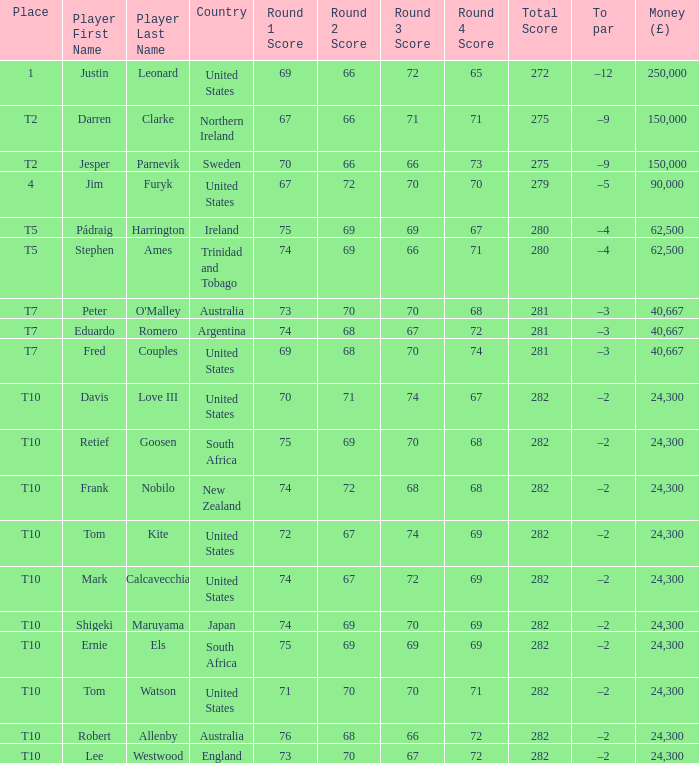What is the money won by Frank Nobilo? 1.0. 